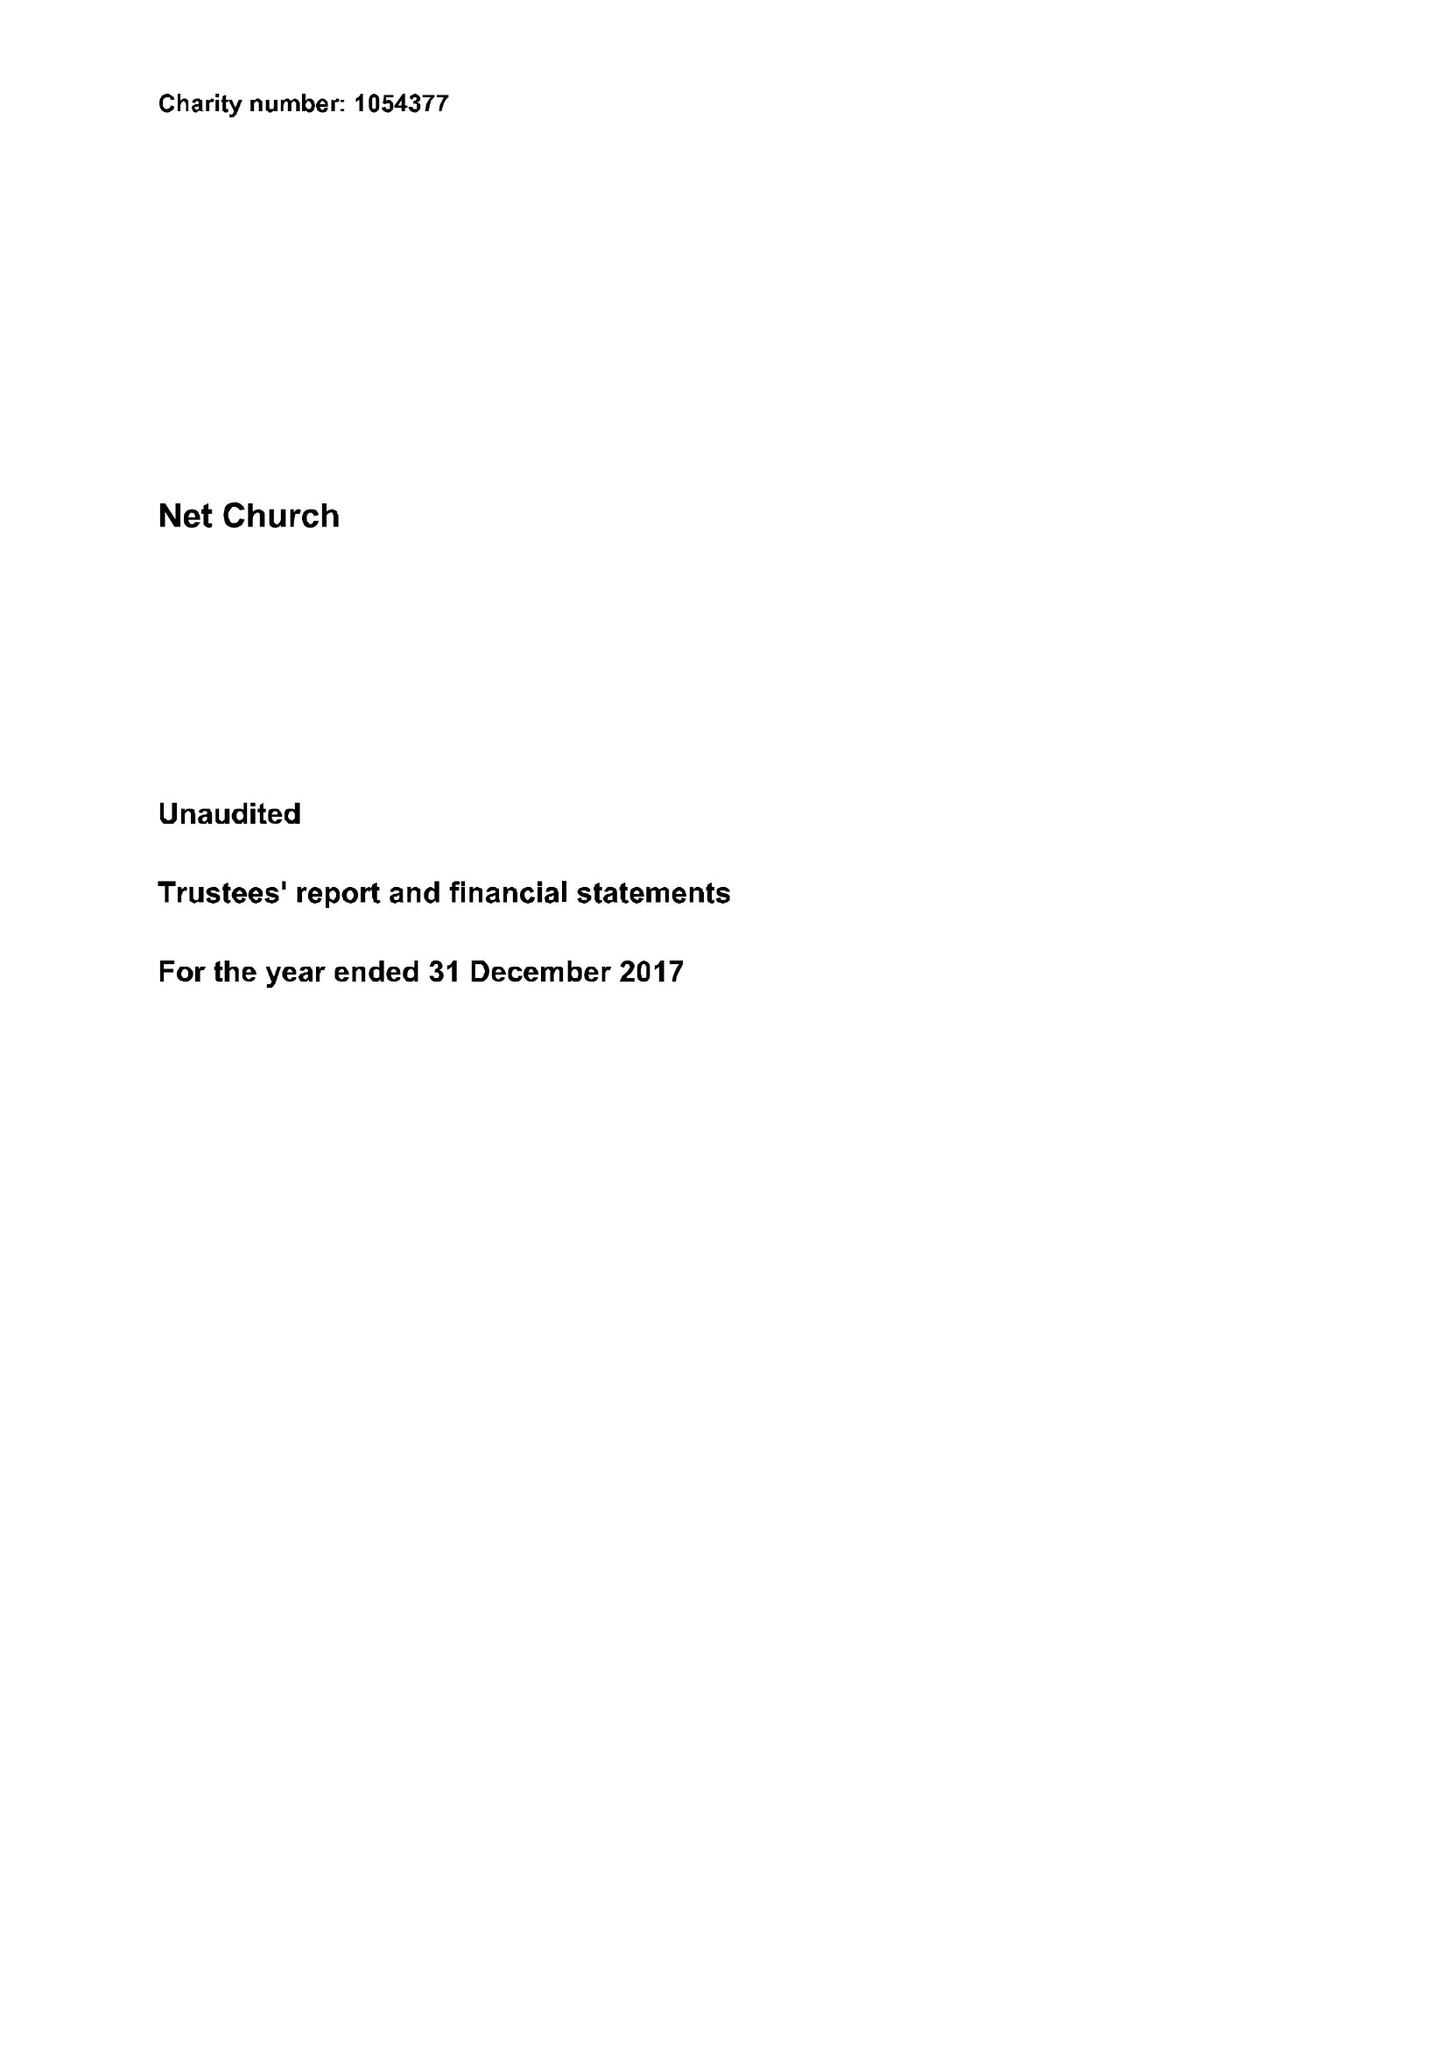What is the value for the income_annually_in_british_pounds?
Answer the question using a single word or phrase. 219443.00 